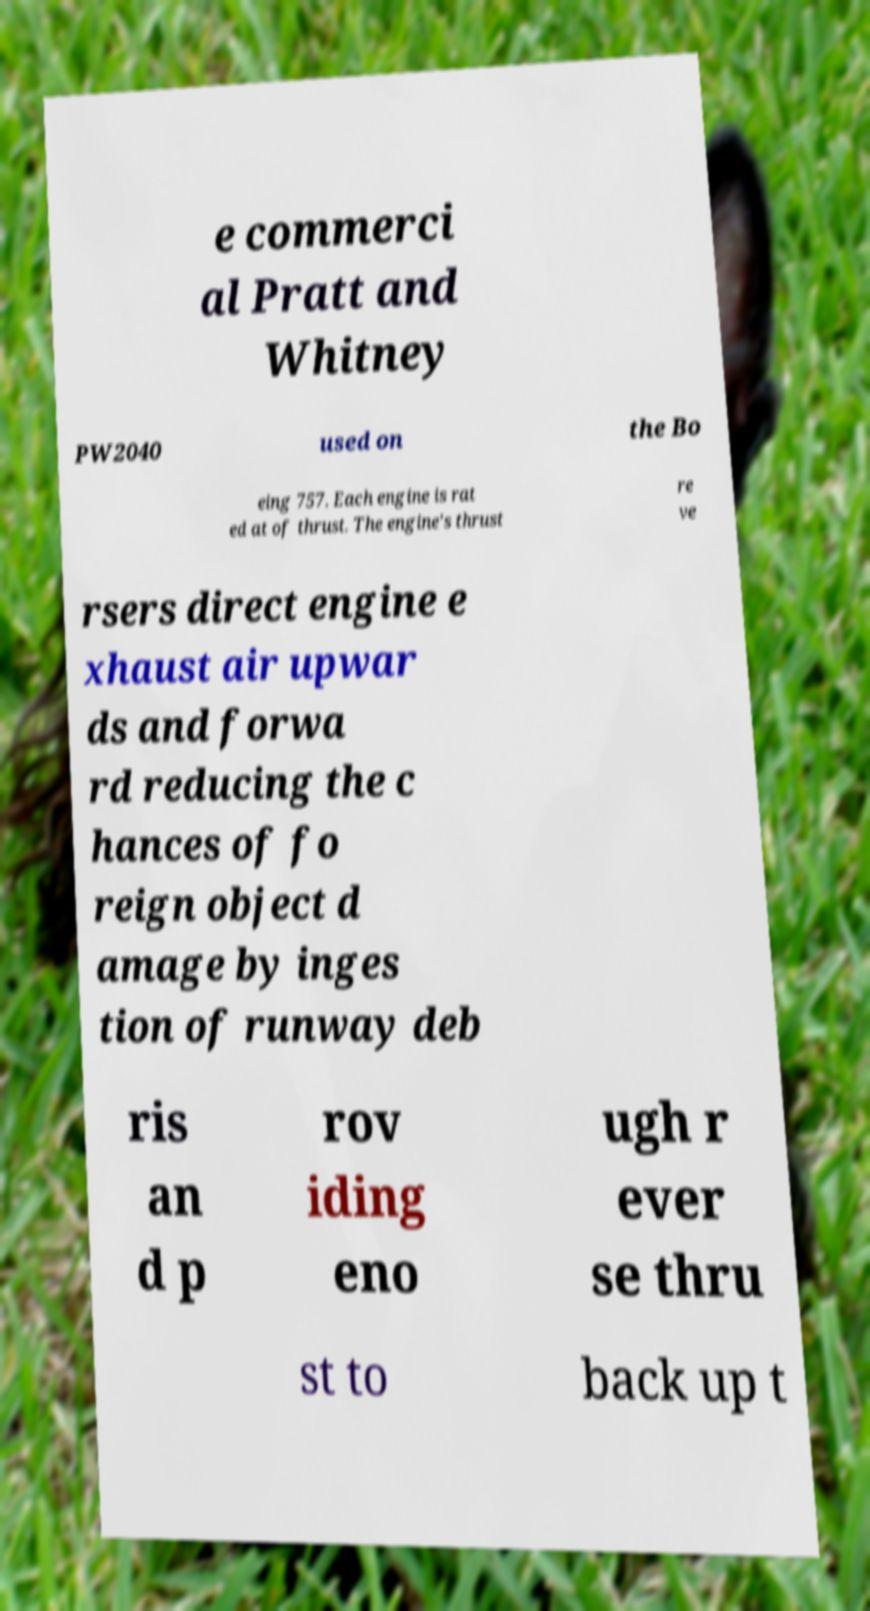Please identify and transcribe the text found in this image. e commerci al Pratt and Whitney PW2040 used on the Bo eing 757. Each engine is rat ed at of thrust. The engine's thrust re ve rsers direct engine e xhaust air upwar ds and forwa rd reducing the c hances of fo reign object d amage by inges tion of runway deb ris an d p rov iding eno ugh r ever se thru st to back up t 